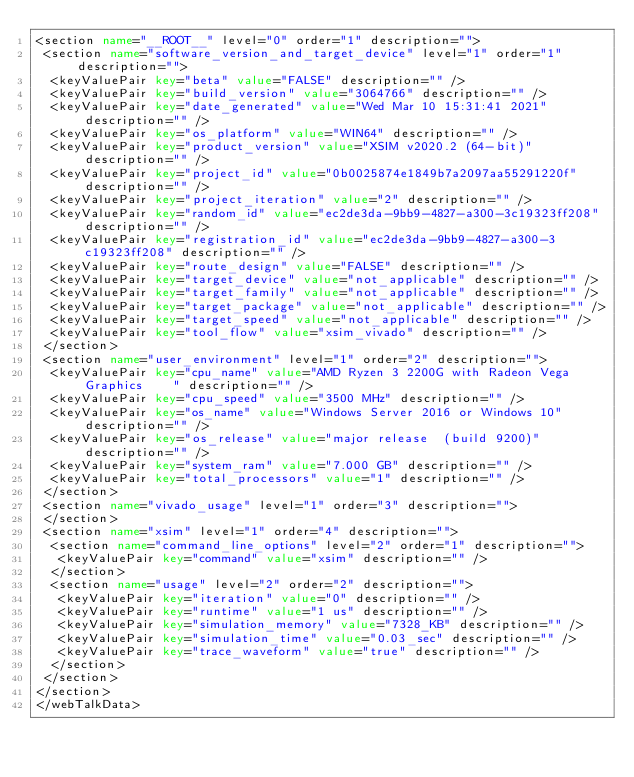Convert code to text. <code><loc_0><loc_0><loc_500><loc_500><_XML_><section name="__ROOT__" level="0" order="1" description="">
 <section name="software_version_and_target_device" level="1" order="1" description="">
  <keyValuePair key="beta" value="FALSE" description="" />
  <keyValuePair key="build_version" value="3064766" description="" />
  <keyValuePair key="date_generated" value="Wed Mar 10 15:31:41 2021" description="" />
  <keyValuePair key="os_platform" value="WIN64" description="" />
  <keyValuePair key="product_version" value="XSIM v2020.2 (64-bit)" description="" />
  <keyValuePair key="project_id" value="0b0025874e1849b7a2097aa55291220f" description="" />
  <keyValuePair key="project_iteration" value="2" description="" />
  <keyValuePair key="random_id" value="ec2de3da-9bb9-4827-a300-3c19323ff208" description="" />
  <keyValuePair key="registration_id" value="ec2de3da-9bb9-4827-a300-3c19323ff208" description="" />
  <keyValuePair key="route_design" value="FALSE" description="" />
  <keyValuePair key="target_device" value="not_applicable" description="" />
  <keyValuePair key="target_family" value="not_applicable" description="" />
  <keyValuePair key="target_package" value="not_applicable" description="" />
  <keyValuePair key="target_speed" value="not_applicable" description="" />
  <keyValuePair key="tool_flow" value="xsim_vivado" description="" />
 </section>
 <section name="user_environment" level="1" order="2" description="">
  <keyValuePair key="cpu_name" value="AMD Ryzen 3 2200G with Radeon Vega Graphics    " description="" />
  <keyValuePair key="cpu_speed" value="3500 MHz" description="" />
  <keyValuePair key="os_name" value="Windows Server 2016 or Windows 10" description="" />
  <keyValuePair key="os_release" value="major release  (build 9200)" description="" />
  <keyValuePair key="system_ram" value="7.000 GB" description="" />
  <keyValuePair key="total_processors" value="1" description="" />
 </section>
 <section name="vivado_usage" level="1" order="3" description="">
 </section>
 <section name="xsim" level="1" order="4" description="">
  <section name="command_line_options" level="2" order="1" description="">
   <keyValuePair key="command" value="xsim" description="" />
  </section>
  <section name="usage" level="2" order="2" description="">
   <keyValuePair key="iteration" value="0" description="" />
   <keyValuePair key="runtime" value="1 us" description="" />
   <keyValuePair key="simulation_memory" value="7328_KB" description="" />
   <keyValuePair key="simulation_time" value="0.03_sec" description="" />
   <keyValuePair key="trace_waveform" value="true" description="" />
  </section>
 </section>
</section>
</webTalkData>
</code> 